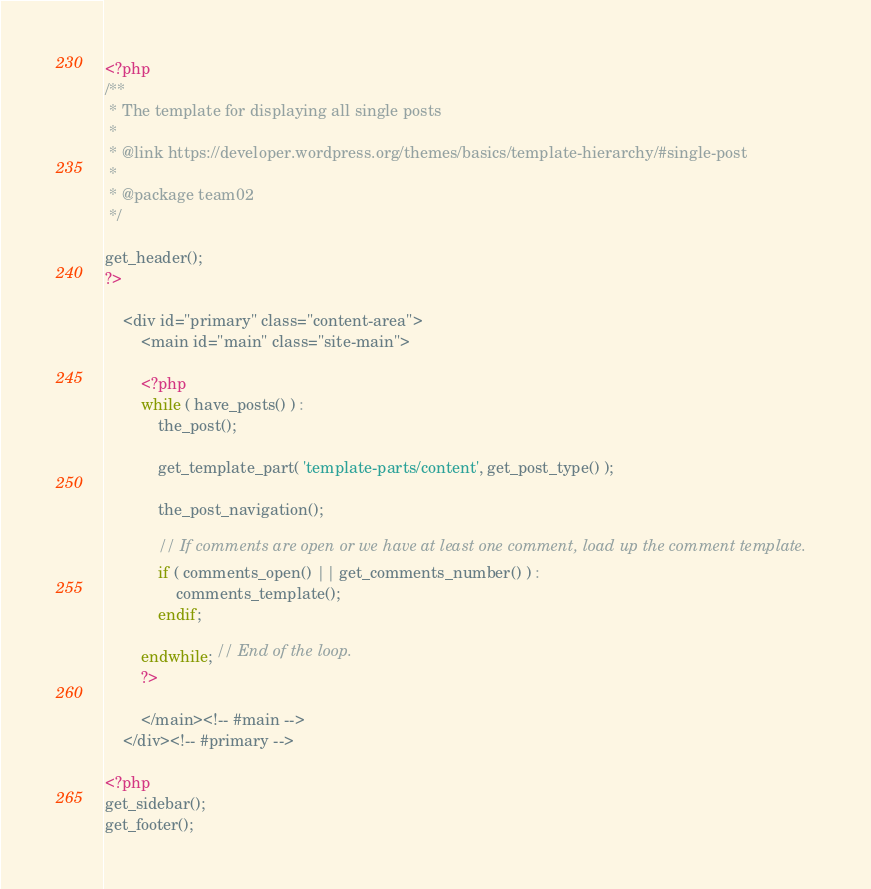<code> <loc_0><loc_0><loc_500><loc_500><_PHP_><?php
/**
 * The template for displaying all single posts
 *
 * @link https://developer.wordpress.org/themes/basics/template-hierarchy/#single-post
 *
 * @package team02
 */

get_header();
?>

	<div id="primary" class="content-area">
		<main id="main" class="site-main">

		<?php
		while ( have_posts() ) :
			the_post();

			get_template_part( 'template-parts/content', get_post_type() );

			the_post_navigation();

			// If comments are open or we have at least one comment, load up the comment template.
			if ( comments_open() || get_comments_number() ) :
				comments_template();
			endif;

		endwhile; // End of the loop.
		?>

		</main><!-- #main -->
	</div><!-- #primary -->

<?php
get_sidebar();
get_footer();
</code> 